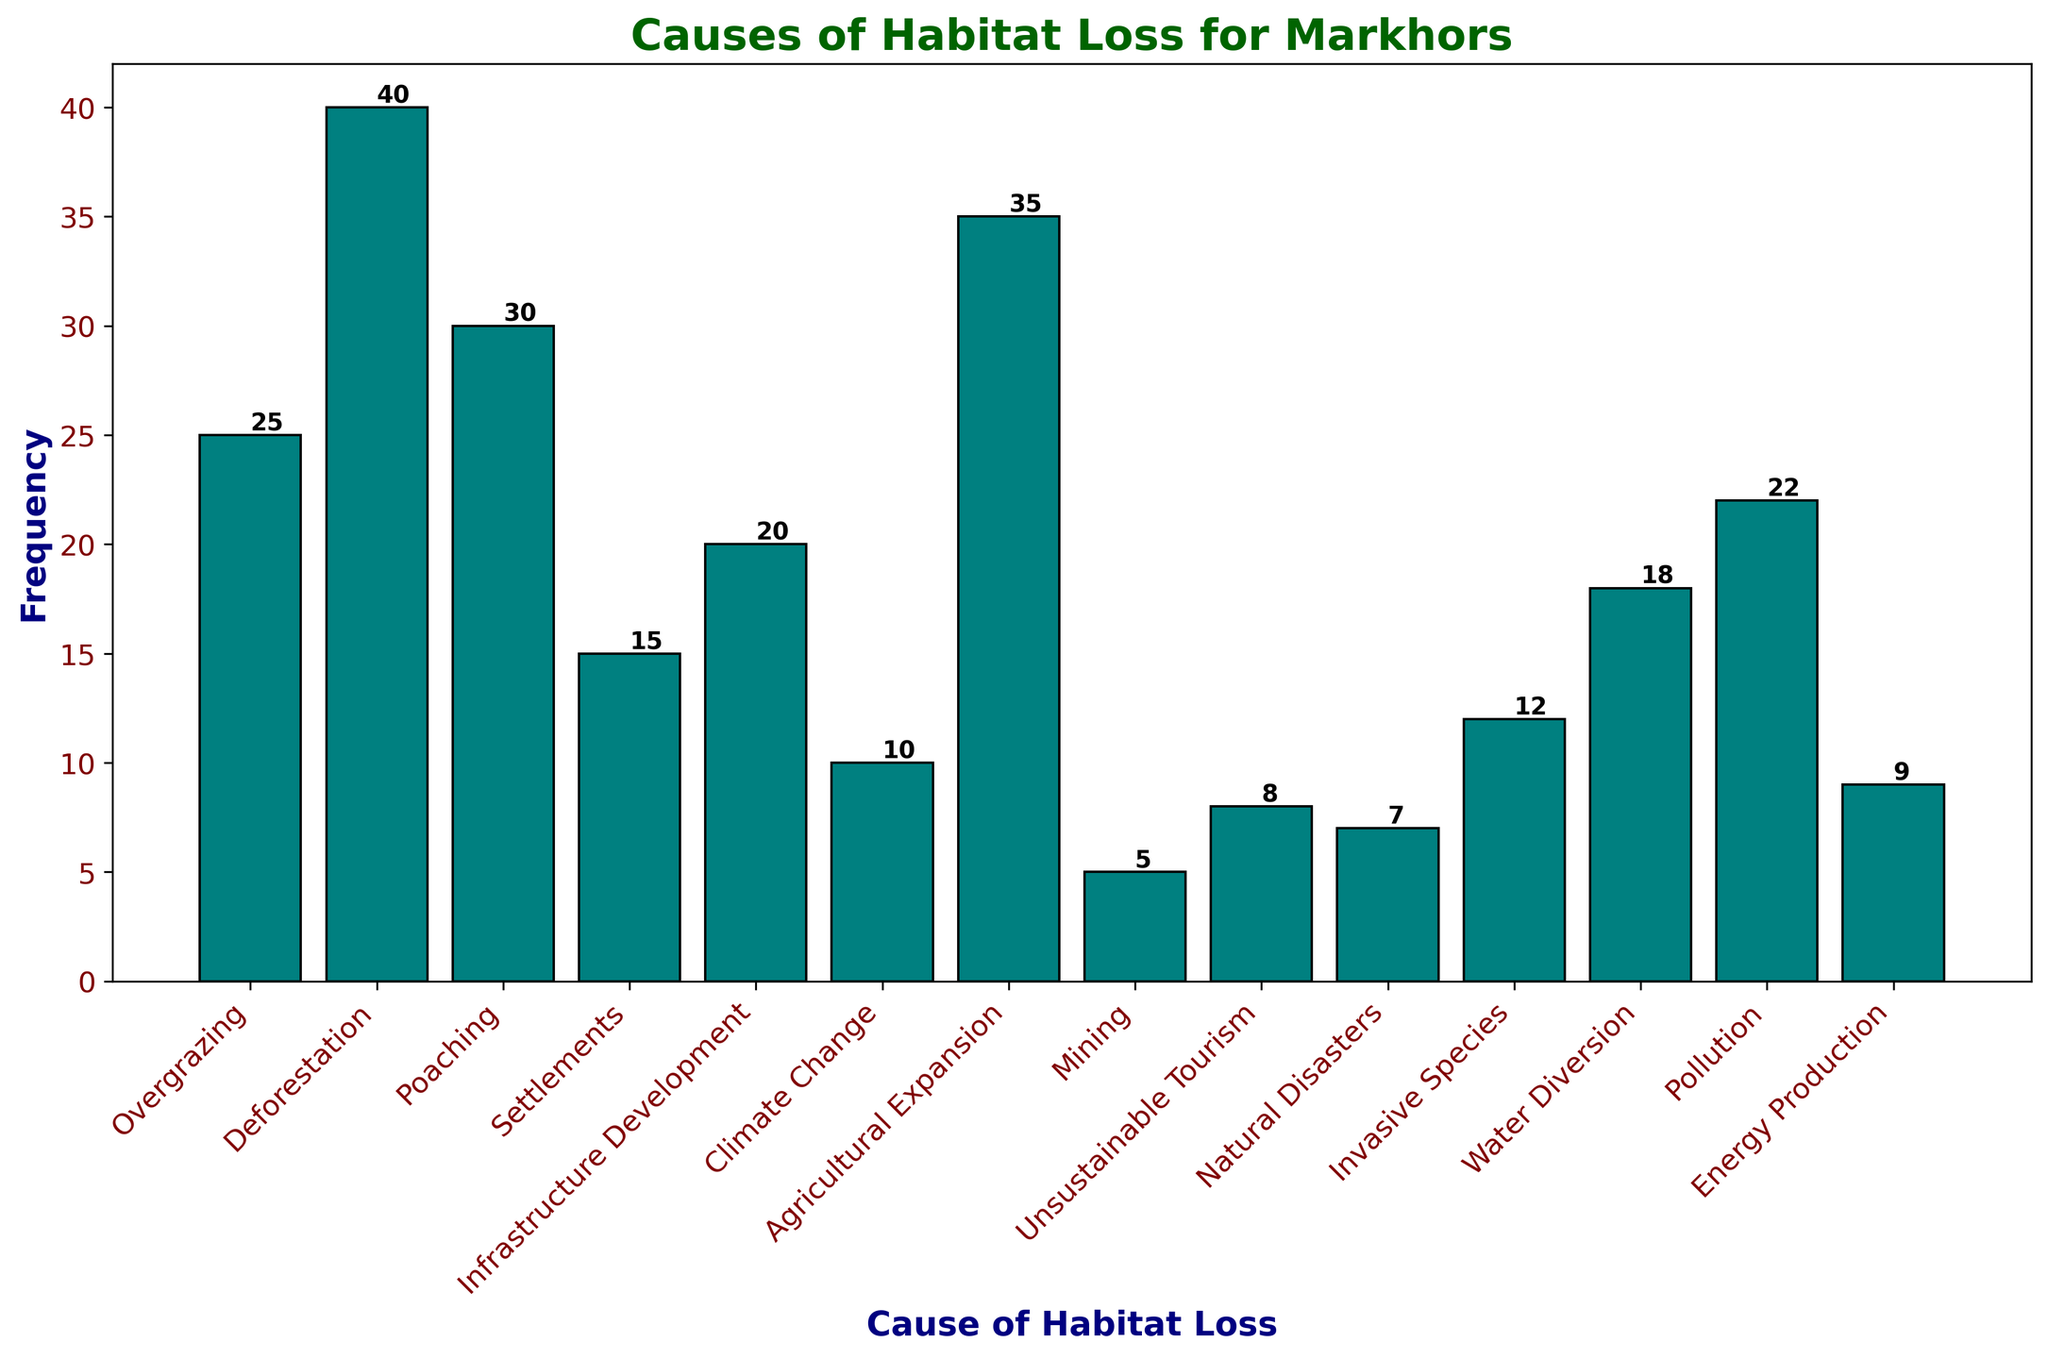What is the most frequent cause of habitat loss for Markhors? The highest bar represents the most frequent cause of habitat loss. The bar for Deforestation is the tallest in the histogram.
Answer: Deforestation Which causes of habitat loss have a frequency less than 10? Identify the bars shorter than the value corresponding to the frequency of 10 on the y-axis. Mining, Unsustainable Tourism, Natural Disasters, and Energy Production are below 10.
Answer: Mining, Unsustainable Tourism, Natural Disasters, Energy Production How many total habitat loss causes are represented in the figure? Count the number of individual bars in the histogram. Each bar represents a different cause. There are 14 bars.
Answer: 14 Which cause of habitat loss is the least frequent? The shortest bar represents the least frequent cause of habitat loss. Mining has the shortest bar in the histogram.
Answer: Mining What is the combined frequency of Overgrazing, Settlements, and Infrastructure Development? Sum the frequencies of Overgrazing (25), Settlements (15), and Infrastructure Development (20). The calculation is 25 + 15 + 20 = 60.
Answer: 60 How does the frequency of Agricultural Expansion compare to that of Poaching? Compare the heights of the bars for Agricultural Expansion and Poaching. Agricultural Expansion (35) is higher than Poaching (30).
Answer: Agricultural Expansion is higher Are any causes of habitat loss tied in frequency? If so, which ones? Look for bars of equal height in the histogram. There are no bars with the same heights, so no ties in frequency.
Answer: No What is the difference in frequency between Water Diversion and Pollution? Subtract the frequency of Water Diversion (18) from Pollution (22). The difference is 22 - 18 = 4.
Answer: 4 Which cause of habitat loss has a slightly higher frequency than Unsustainable Tourism? Identify which bar has a frequency slightly higher than Unsustainable Tourism (8). The bar for Natural Disasters (7) is slightly lower, so nothing is slightly higher.
Answer: None What is the sum of the frequencies of all causes of habitat loss? Sum all the frequencies: 25 + 40 + 30 + 15 + 20 + 10 + 35 + 5 + 8 + 7 + 12 + 18 + 22 + 9 = 256.
Answer: 256 